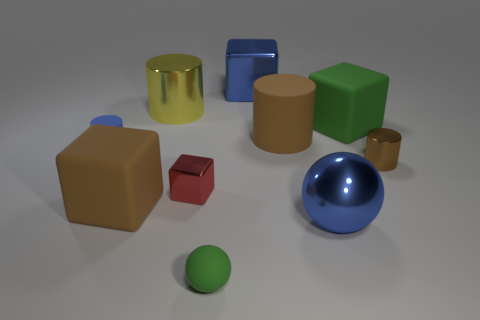Are there fewer small red shiny blocks to the right of the large brown cylinder than small red metal things that are on the left side of the large green thing?
Your answer should be compact. Yes. What is the color of the metallic cube that is left of the large blue shiny cube?
Offer a terse response. Red. How many other things are the same color as the large matte cylinder?
Give a very brief answer. 2. There is a matte cylinder on the right side of the blue metal block; is its size the same as the big metallic cylinder?
Keep it short and to the point. Yes. How many things are to the left of the red metal thing?
Keep it short and to the point. 3. Are there any blue cylinders that have the same size as the yellow shiny object?
Make the answer very short. No. Do the shiny ball and the small rubber ball have the same color?
Offer a very short reply. No. What color is the small cylinder that is to the left of the big cylinder on the left side of the small cube?
Ensure brevity in your answer.  Blue. How many objects are in front of the large blue block and behind the small brown cylinder?
Provide a succinct answer. 4. How many tiny brown things are the same shape as the small blue matte thing?
Make the answer very short. 1. 